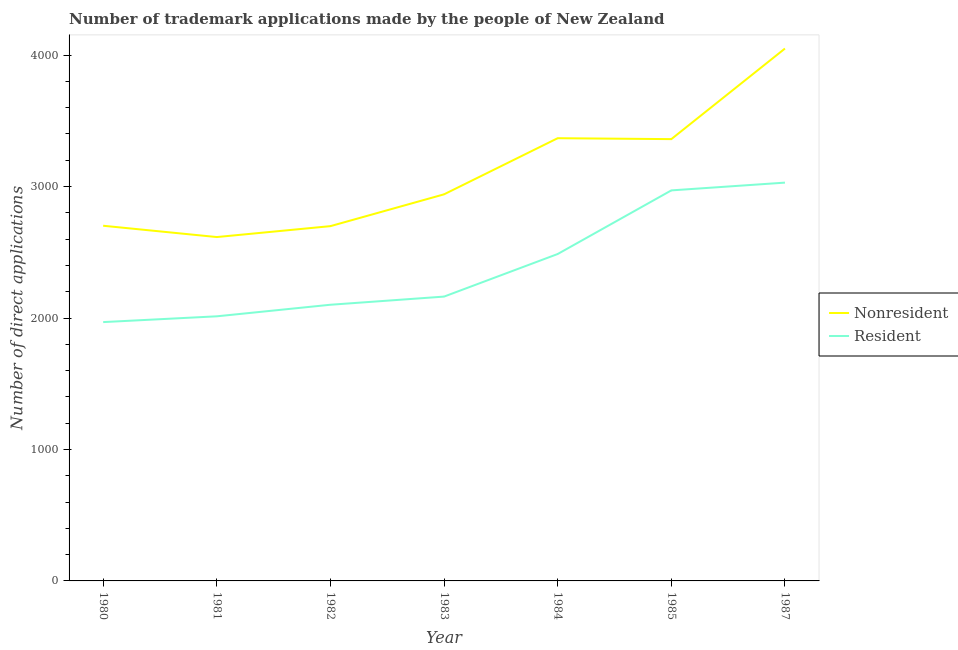What is the number of trademark applications made by residents in 1980?
Make the answer very short. 1969. Across all years, what is the maximum number of trademark applications made by non residents?
Provide a short and direct response. 4050. Across all years, what is the minimum number of trademark applications made by non residents?
Ensure brevity in your answer.  2616. In which year was the number of trademark applications made by non residents minimum?
Your answer should be very brief. 1981. What is the total number of trademark applications made by residents in the graph?
Make the answer very short. 1.67e+04. What is the difference between the number of trademark applications made by residents in 1980 and that in 1981?
Keep it short and to the point. -44. What is the difference between the number of trademark applications made by non residents in 1985 and the number of trademark applications made by residents in 1987?
Ensure brevity in your answer.  331. What is the average number of trademark applications made by residents per year?
Keep it short and to the point. 2390.57. In the year 1983, what is the difference between the number of trademark applications made by non residents and number of trademark applications made by residents?
Make the answer very short. 778. What is the ratio of the number of trademark applications made by non residents in 1984 to that in 1985?
Offer a terse response. 1. Is the number of trademark applications made by non residents in 1983 less than that in 1985?
Make the answer very short. Yes. What is the difference between the highest and the second highest number of trademark applications made by non residents?
Your answer should be very brief. 682. What is the difference between the highest and the lowest number of trademark applications made by residents?
Give a very brief answer. 1061. In how many years, is the number of trademark applications made by non residents greater than the average number of trademark applications made by non residents taken over all years?
Give a very brief answer. 3. Does the number of trademark applications made by residents monotonically increase over the years?
Make the answer very short. Yes. Is the number of trademark applications made by residents strictly less than the number of trademark applications made by non residents over the years?
Provide a succinct answer. Yes. How many lines are there?
Provide a short and direct response. 2. How many years are there in the graph?
Your response must be concise. 7. Does the graph contain grids?
Offer a very short reply. No. Where does the legend appear in the graph?
Your answer should be very brief. Center right. What is the title of the graph?
Offer a terse response. Number of trademark applications made by the people of New Zealand. Does "Official aid received" appear as one of the legend labels in the graph?
Provide a short and direct response. No. What is the label or title of the Y-axis?
Provide a short and direct response. Number of direct applications. What is the Number of direct applications of Nonresident in 1980?
Your answer should be very brief. 2702. What is the Number of direct applications of Resident in 1980?
Offer a terse response. 1969. What is the Number of direct applications in Nonresident in 1981?
Ensure brevity in your answer.  2616. What is the Number of direct applications in Resident in 1981?
Offer a terse response. 2013. What is the Number of direct applications of Nonresident in 1982?
Give a very brief answer. 2699. What is the Number of direct applications in Resident in 1982?
Your answer should be very brief. 2101. What is the Number of direct applications of Nonresident in 1983?
Make the answer very short. 2941. What is the Number of direct applications in Resident in 1983?
Provide a short and direct response. 2163. What is the Number of direct applications of Nonresident in 1984?
Keep it short and to the point. 3368. What is the Number of direct applications in Resident in 1984?
Provide a short and direct response. 2487. What is the Number of direct applications of Nonresident in 1985?
Give a very brief answer. 3361. What is the Number of direct applications in Resident in 1985?
Ensure brevity in your answer.  2971. What is the Number of direct applications of Nonresident in 1987?
Your answer should be very brief. 4050. What is the Number of direct applications in Resident in 1987?
Ensure brevity in your answer.  3030. Across all years, what is the maximum Number of direct applications in Nonresident?
Offer a very short reply. 4050. Across all years, what is the maximum Number of direct applications of Resident?
Your response must be concise. 3030. Across all years, what is the minimum Number of direct applications in Nonresident?
Ensure brevity in your answer.  2616. Across all years, what is the minimum Number of direct applications of Resident?
Ensure brevity in your answer.  1969. What is the total Number of direct applications in Nonresident in the graph?
Offer a very short reply. 2.17e+04. What is the total Number of direct applications in Resident in the graph?
Provide a succinct answer. 1.67e+04. What is the difference between the Number of direct applications in Nonresident in 1980 and that in 1981?
Make the answer very short. 86. What is the difference between the Number of direct applications of Resident in 1980 and that in 1981?
Your response must be concise. -44. What is the difference between the Number of direct applications in Nonresident in 1980 and that in 1982?
Your answer should be compact. 3. What is the difference between the Number of direct applications of Resident in 1980 and that in 1982?
Provide a succinct answer. -132. What is the difference between the Number of direct applications of Nonresident in 1980 and that in 1983?
Your answer should be very brief. -239. What is the difference between the Number of direct applications of Resident in 1980 and that in 1983?
Your answer should be compact. -194. What is the difference between the Number of direct applications of Nonresident in 1980 and that in 1984?
Provide a succinct answer. -666. What is the difference between the Number of direct applications of Resident in 1980 and that in 1984?
Your answer should be very brief. -518. What is the difference between the Number of direct applications in Nonresident in 1980 and that in 1985?
Keep it short and to the point. -659. What is the difference between the Number of direct applications of Resident in 1980 and that in 1985?
Keep it short and to the point. -1002. What is the difference between the Number of direct applications in Nonresident in 1980 and that in 1987?
Offer a very short reply. -1348. What is the difference between the Number of direct applications of Resident in 1980 and that in 1987?
Offer a terse response. -1061. What is the difference between the Number of direct applications of Nonresident in 1981 and that in 1982?
Keep it short and to the point. -83. What is the difference between the Number of direct applications in Resident in 1981 and that in 1982?
Your answer should be compact. -88. What is the difference between the Number of direct applications in Nonresident in 1981 and that in 1983?
Your response must be concise. -325. What is the difference between the Number of direct applications in Resident in 1981 and that in 1983?
Offer a terse response. -150. What is the difference between the Number of direct applications of Nonresident in 1981 and that in 1984?
Make the answer very short. -752. What is the difference between the Number of direct applications of Resident in 1981 and that in 1984?
Give a very brief answer. -474. What is the difference between the Number of direct applications in Nonresident in 1981 and that in 1985?
Give a very brief answer. -745. What is the difference between the Number of direct applications of Resident in 1981 and that in 1985?
Give a very brief answer. -958. What is the difference between the Number of direct applications of Nonresident in 1981 and that in 1987?
Provide a succinct answer. -1434. What is the difference between the Number of direct applications of Resident in 1981 and that in 1987?
Provide a succinct answer. -1017. What is the difference between the Number of direct applications of Nonresident in 1982 and that in 1983?
Offer a very short reply. -242. What is the difference between the Number of direct applications in Resident in 1982 and that in 1983?
Make the answer very short. -62. What is the difference between the Number of direct applications in Nonresident in 1982 and that in 1984?
Offer a very short reply. -669. What is the difference between the Number of direct applications in Resident in 1982 and that in 1984?
Ensure brevity in your answer.  -386. What is the difference between the Number of direct applications in Nonresident in 1982 and that in 1985?
Ensure brevity in your answer.  -662. What is the difference between the Number of direct applications in Resident in 1982 and that in 1985?
Ensure brevity in your answer.  -870. What is the difference between the Number of direct applications in Nonresident in 1982 and that in 1987?
Provide a succinct answer. -1351. What is the difference between the Number of direct applications of Resident in 1982 and that in 1987?
Your answer should be compact. -929. What is the difference between the Number of direct applications in Nonresident in 1983 and that in 1984?
Ensure brevity in your answer.  -427. What is the difference between the Number of direct applications in Resident in 1983 and that in 1984?
Offer a very short reply. -324. What is the difference between the Number of direct applications in Nonresident in 1983 and that in 1985?
Offer a very short reply. -420. What is the difference between the Number of direct applications in Resident in 1983 and that in 1985?
Offer a terse response. -808. What is the difference between the Number of direct applications in Nonresident in 1983 and that in 1987?
Offer a very short reply. -1109. What is the difference between the Number of direct applications of Resident in 1983 and that in 1987?
Your response must be concise. -867. What is the difference between the Number of direct applications in Resident in 1984 and that in 1985?
Keep it short and to the point. -484. What is the difference between the Number of direct applications of Nonresident in 1984 and that in 1987?
Provide a short and direct response. -682. What is the difference between the Number of direct applications of Resident in 1984 and that in 1987?
Make the answer very short. -543. What is the difference between the Number of direct applications of Nonresident in 1985 and that in 1987?
Your answer should be very brief. -689. What is the difference between the Number of direct applications in Resident in 1985 and that in 1987?
Offer a terse response. -59. What is the difference between the Number of direct applications of Nonresident in 1980 and the Number of direct applications of Resident in 1981?
Give a very brief answer. 689. What is the difference between the Number of direct applications in Nonresident in 1980 and the Number of direct applications in Resident in 1982?
Your response must be concise. 601. What is the difference between the Number of direct applications of Nonresident in 1980 and the Number of direct applications of Resident in 1983?
Your answer should be compact. 539. What is the difference between the Number of direct applications of Nonresident in 1980 and the Number of direct applications of Resident in 1984?
Your answer should be compact. 215. What is the difference between the Number of direct applications of Nonresident in 1980 and the Number of direct applications of Resident in 1985?
Provide a succinct answer. -269. What is the difference between the Number of direct applications in Nonresident in 1980 and the Number of direct applications in Resident in 1987?
Keep it short and to the point. -328. What is the difference between the Number of direct applications in Nonresident in 1981 and the Number of direct applications in Resident in 1982?
Ensure brevity in your answer.  515. What is the difference between the Number of direct applications in Nonresident in 1981 and the Number of direct applications in Resident in 1983?
Ensure brevity in your answer.  453. What is the difference between the Number of direct applications of Nonresident in 1981 and the Number of direct applications of Resident in 1984?
Offer a terse response. 129. What is the difference between the Number of direct applications of Nonresident in 1981 and the Number of direct applications of Resident in 1985?
Your answer should be compact. -355. What is the difference between the Number of direct applications of Nonresident in 1981 and the Number of direct applications of Resident in 1987?
Offer a very short reply. -414. What is the difference between the Number of direct applications of Nonresident in 1982 and the Number of direct applications of Resident in 1983?
Make the answer very short. 536. What is the difference between the Number of direct applications in Nonresident in 1982 and the Number of direct applications in Resident in 1984?
Offer a very short reply. 212. What is the difference between the Number of direct applications in Nonresident in 1982 and the Number of direct applications in Resident in 1985?
Offer a terse response. -272. What is the difference between the Number of direct applications of Nonresident in 1982 and the Number of direct applications of Resident in 1987?
Your answer should be very brief. -331. What is the difference between the Number of direct applications of Nonresident in 1983 and the Number of direct applications of Resident in 1984?
Provide a short and direct response. 454. What is the difference between the Number of direct applications in Nonresident in 1983 and the Number of direct applications in Resident in 1987?
Give a very brief answer. -89. What is the difference between the Number of direct applications of Nonresident in 1984 and the Number of direct applications of Resident in 1985?
Your answer should be very brief. 397. What is the difference between the Number of direct applications in Nonresident in 1984 and the Number of direct applications in Resident in 1987?
Make the answer very short. 338. What is the difference between the Number of direct applications of Nonresident in 1985 and the Number of direct applications of Resident in 1987?
Keep it short and to the point. 331. What is the average Number of direct applications of Nonresident per year?
Offer a very short reply. 3105.29. What is the average Number of direct applications of Resident per year?
Your answer should be compact. 2390.57. In the year 1980, what is the difference between the Number of direct applications of Nonresident and Number of direct applications of Resident?
Provide a succinct answer. 733. In the year 1981, what is the difference between the Number of direct applications of Nonresident and Number of direct applications of Resident?
Keep it short and to the point. 603. In the year 1982, what is the difference between the Number of direct applications of Nonresident and Number of direct applications of Resident?
Provide a short and direct response. 598. In the year 1983, what is the difference between the Number of direct applications of Nonresident and Number of direct applications of Resident?
Your answer should be compact. 778. In the year 1984, what is the difference between the Number of direct applications in Nonresident and Number of direct applications in Resident?
Provide a short and direct response. 881. In the year 1985, what is the difference between the Number of direct applications of Nonresident and Number of direct applications of Resident?
Provide a short and direct response. 390. In the year 1987, what is the difference between the Number of direct applications of Nonresident and Number of direct applications of Resident?
Offer a very short reply. 1020. What is the ratio of the Number of direct applications in Nonresident in 1980 to that in 1981?
Offer a very short reply. 1.03. What is the ratio of the Number of direct applications in Resident in 1980 to that in 1981?
Provide a succinct answer. 0.98. What is the ratio of the Number of direct applications of Nonresident in 1980 to that in 1982?
Provide a succinct answer. 1. What is the ratio of the Number of direct applications of Resident in 1980 to that in 1982?
Make the answer very short. 0.94. What is the ratio of the Number of direct applications of Nonresident in 1980 to that in 1983?
Offer a terse response. 0.92. What is the ratio of the Number of direct applications in Resident in 1980 to that in 1983?
Your answer should be compact. 0.91. What is the ratio of the Number of direct applications in Nonresident in 1980 to that in 1984?
Give a very brief answer. 0.8. What is the ratio of the Number of direct applications of Resident in 1980 to that in 1984?
Provide a succinct answer. 0.79. What is the ratio of the Number of direct applications of Nonresident in 1980 to that in 1985?
Your answer should be compact. 0.8. What is the ratio of the Number of direct applications of Resident in 1980 to that in 1985?
Your response must be concise. 0.66. What is the ratio of the Number of direct applications of Nonresident in 1980 to that in 1987?
Offer a terse response. 0.67. What is the ratio of the Number of direct applications in Resident in 1980 to that in 1987?
Offer a very short reply. 0.65. What is the ratio of the Number of direct applications in Nonresident in 1981 to that in 1982?
Provide a short and direct response. 0.97. What is the ratio of the Number of direct applications of Resident in 1981 to that in 1982?
Your answer should be very brief. 0.96. What is the ratio of the Number of direct applications in Nonresident in 1981 to that in 1983?
Offer a terse response. 0.89. What is the ratio of the Number of direct applications of Resident in 1981 to that in 1983?
Your answer should be very brief. 0.93. What is the ratio of the Number of direct applications in Nonresident in 1981 to that in 1984?
Offer a very short reply. 0.78. What is the ratio of the Number of direct applications in Resident in 1981 to that in 1984?
Your answer should be very brief. 0.81. What is the ratio of the Number of direct applications in Nonresident in 1981 to that in 1985?
Offer a very short reply. 0.78. What is the ratio of the Number of direct applications in Resident in 1981 to that in 1985?
Make the answer very short. 0.68. What is the ratio of the Number of direct applications of Nonresident in 1981 to that in 1987?
Ensure brevity in your answer.  0.65. What is the ratio of the Number of direct applications of Resident in 1981 to that in 1987?
Make the answer very short. 0.66. What is the ratio of the Number of direct applications in Nonresident in 1982 to that in 1983?
Provide a succinct answer. 0.92. What is the ratio of the Number of direct applications in Resident in 1982 to that in 1983?
Ensure brevity in your answer.  0.97. What is the ratio of the Number of direct applications of Nonresident in 1982 to that in 1984?
Your response must be concise. 0.8. What is the ratio of the Number of direct applications in Resident in 1982 to that in 1984?
Offer a very short reply. 0.84. What is the ratio of the Number of direct applications of Nonresident in 1982 to that in 1985?
Your answer should be very brief. 0.8. What is the ratio of the Number of direct applications in Resident in 1982 to that in 1985?
Provide a succinct answer. 0.71. What is the ratio of the Number of direct applications of Nonresident in 1982 to that in 1987?
Offer a terse response. 0.67. What is the ratio of the Number of direct applications in Resident in 1982 to that in 1987?
Ensure brevity in your answer.  0.69. What is the ratio of the Number of direct applications in Nonresident in 1983 to that in 1984?
Offer a terse response. 0.87. What is the ratio of the Number of direct applications in Resident in 1983 to that in 1984?
Give a very brief answer. 0.87. What is the ratio of the Number of direct applications in Resident in 1983 to that in 1985?
Give a very brief answer. 0.73. What is the ratio of the Number of direct applications of Nonresident in 1983 to that in 1987?
Your answer should be compact. 0.73. What is the ratio of the Number of direct applications of Resident in 1983 to that in 1987?
Provide a succinct answer. 0.71. What is the ratio of the Number of direct applications in Resident in 1984 to that in 1985?
Your answer should be compact. 0.84. What is the ratio of the Number of direct applications of Nonresident in 1984 to that in 1987?
Your answer should be compact. 0.83. What is the ratio of the Number of direct applications of Resident in 1984 to that in 1987?
Give a very brief answer. 0.82. What is the ratio of the Number of direct applications of Nonresident in 1985 to that in 1987?
Keep it short and to the point. 0.83. What is the ratio of the Number of direct applications of Resident in 1985 to that in 1987?
Offer a terse response. 0.98. What is the difference between the highest and the second highest Number of direct applications of Nonresident?
Provide a succinct answer. 682. What is the difference between the highest and the second highest Number of direct applications in Resident?
Provide a succinct answer. 59. What is the difference between the highest and the lowest Number of direct applications of Nonresident?
Your answer should be very brief. 1434. What is the difference between the highest and the lowest Number of direct applications in Resident?
Give a very brief answer. 1061. 